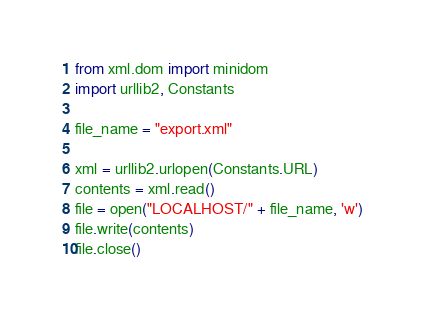Convert code to text. <code><loc_0><loc_0><loc_500><loc_500><_Python_>from xml.dom import minidom
import urllib2, Constants

file_name = "export.xml"

xml = urllib2.urlopen(Constants.URL)
contents = xml.read()
file = open("LOCALHOST/" + file_name, 'w')
file.write(contents)
file.close()</code> 